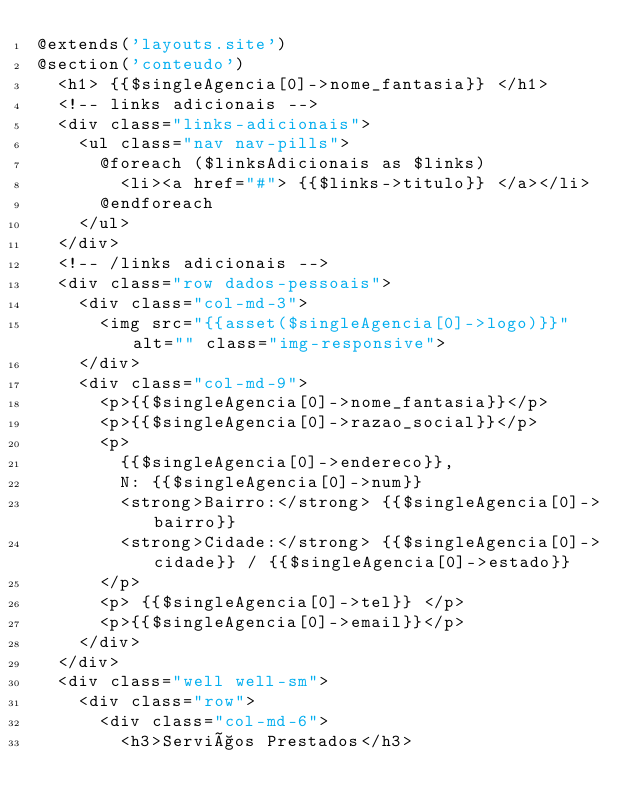Convert code to text. <code><loc_0><loc_0><loc_500><loc_500><_PHP_>@extends('layouts.site')
@section('conteudo')
  <h1> {{$singleAgencia[0]->nome_fantasia}} </h1>
  <!-- links adicionais -->
  <div class="links-adicionais">
    <ul class="nav nav-pills">
      @foreach ($linksAdicionais as $links)
        <li><a href="#"> {{$links->titulo}} </a></li>
      @endforeach
    </ul>
  </div>
  <!-- /links adicionais -->
  <div class="row dados-pessoais">
    <div class="col-md-3">
      <img src="{{asset($singleAgencia[0]->logo)}}" alt="" class="img-responsive">
    </div>
    <div class="col-md-9">
      <p>{{$singleAgencia[0]->nome_fantasia}}</p>
      <p>{{$singleAgencia[0]->razao_social}}</p>
      <p>
        {{$singleAgencia[0]->endereco}},
        N: {{$singleAgencia[0]->num}}
        <strong>Bairro:</strong> {{$singleAgencia[0]->bairro}}
        <strong>Cidade:</strong> {{$singleAgencia[0]->cidade}} / {{$singleAgencia[0]->estado}}
      </p>
      <p> {{$singleAgencia[0]->tel}} </p>
      <p>{{$singleAgencia[0]->email}}</p>
    </div>
  </div>
  <div class="well well-sm">
    <div class="row">
      <div class="col-md-6">
        <h3>Serviços Prestados</h3></code> 